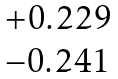<formula> <loc_0><loc_0><loc_500><loc_500>\begin{matrix} + 0 . 2 2 9 \\ - 0 . 2 4 1 \end{matrix}</formula> 